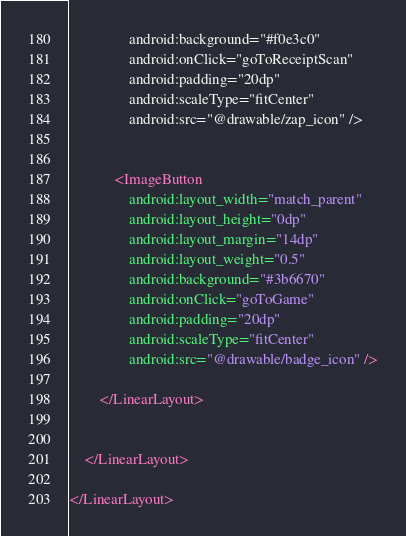Convert code to text. <code><loc_0><loc_0><loc_500><loc_500><_XML_>                android:background="#f0e3c0"
                android:onClick="goToReceiptScan"
                android:padding="20dp"
                android:scaleType="fitCenter"
                android:src="@drawable/zap_icon" />


            <ImageButton
                android:layout_width="match_parent"
                android:layout_height="0dp"
                android:layout_margin="14dp"
                android:layout_weight="0.5"
                android:background="#3b6670"
                android:onClick="goToGame"
                android:padding="20dp"
                android:scaleType="fitCenter"
                android:src="@drawable/badge_icon" />

        </LinearLayout>


    </LinearLayout>

</LinearLayout>
</code> 